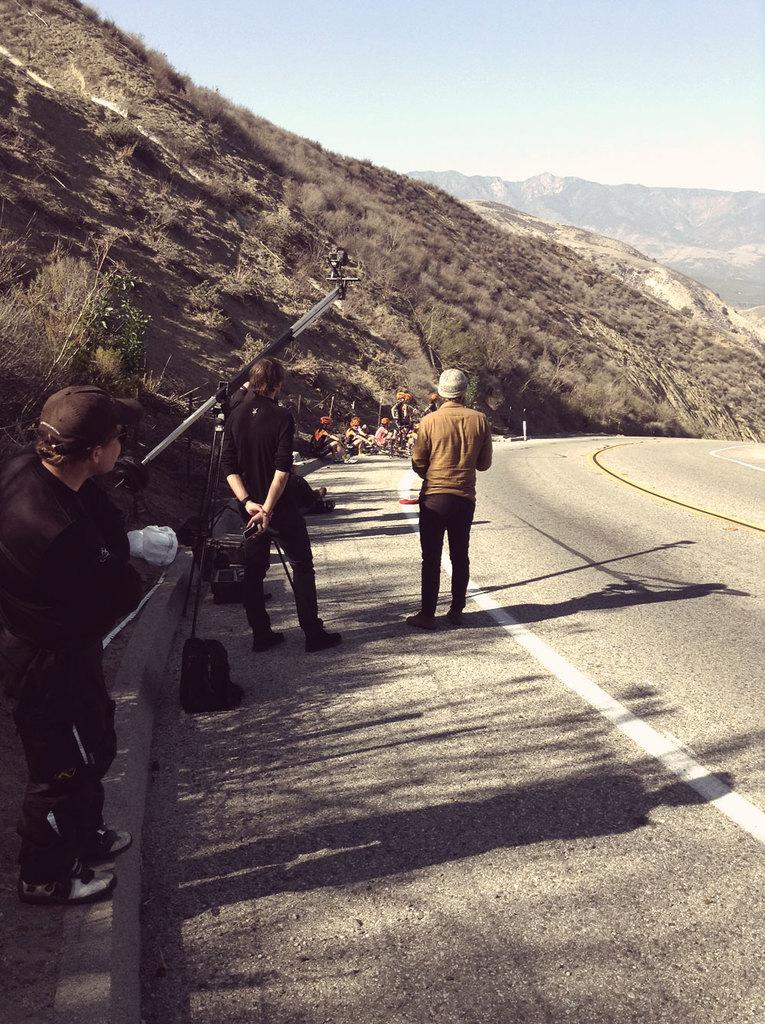What type of landscape can be seen in the image? There are hills in the image. What other natural elements are present in the image? There are trees in the image. Can you describe the people in the image? There are people in the image, and some of them are wearing caps. What items are the people carrying in the image? There are bags in the image. What man-made structures can be seen in the image? There are poles on the road in the image. How many boats can be seen in the image? There are no boats present in the image. What type of heart-shaped object can be seen in the image? There is no heart-shaped object present in the image. 